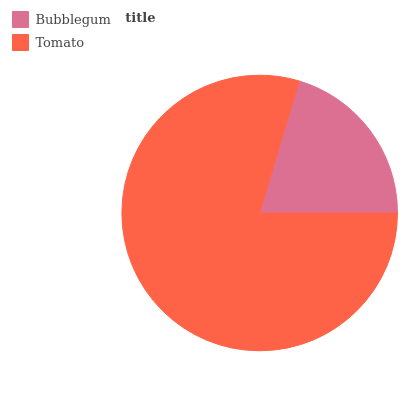Is Bubblegum the minimum?
Answer yes or no. Yes. Is Tomato the maximum?
Answer yes or no. Yes. Is Tomato the minimum?
Answer yes or no. No. Is Tomato greater than Bubblegum?
Answer yes or no. Yes. Is Bubblegum less than Tomato?
Answer yes or no. Yes. Is Bubblegum greater than Tomato?
Answer yes or no. No. Is Tomato less than Bubblegum?
Answer yes or no. No. Is Tomato the high median?
Answer yes or no. Yes. Is Bubblegum the low median?
Answer yes or no. Yes. Is Bubblegum the high median?
Answer yes or no. No. Is Tomato the low median?
Answer yes or no. No. 